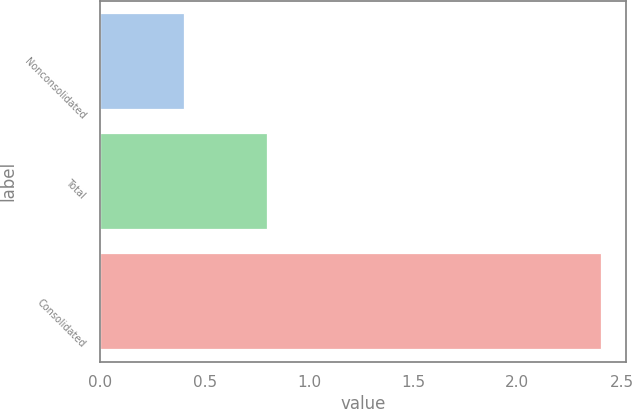<chart> <loc_0><loc_0><loc_500><loc_500><bar_chart><fcel>Nonconsolidated<fcel>Total<fcel>Consolidated<nl><fcel>0.4<fcel>0.8<fcel>2.4<nl></chart> 